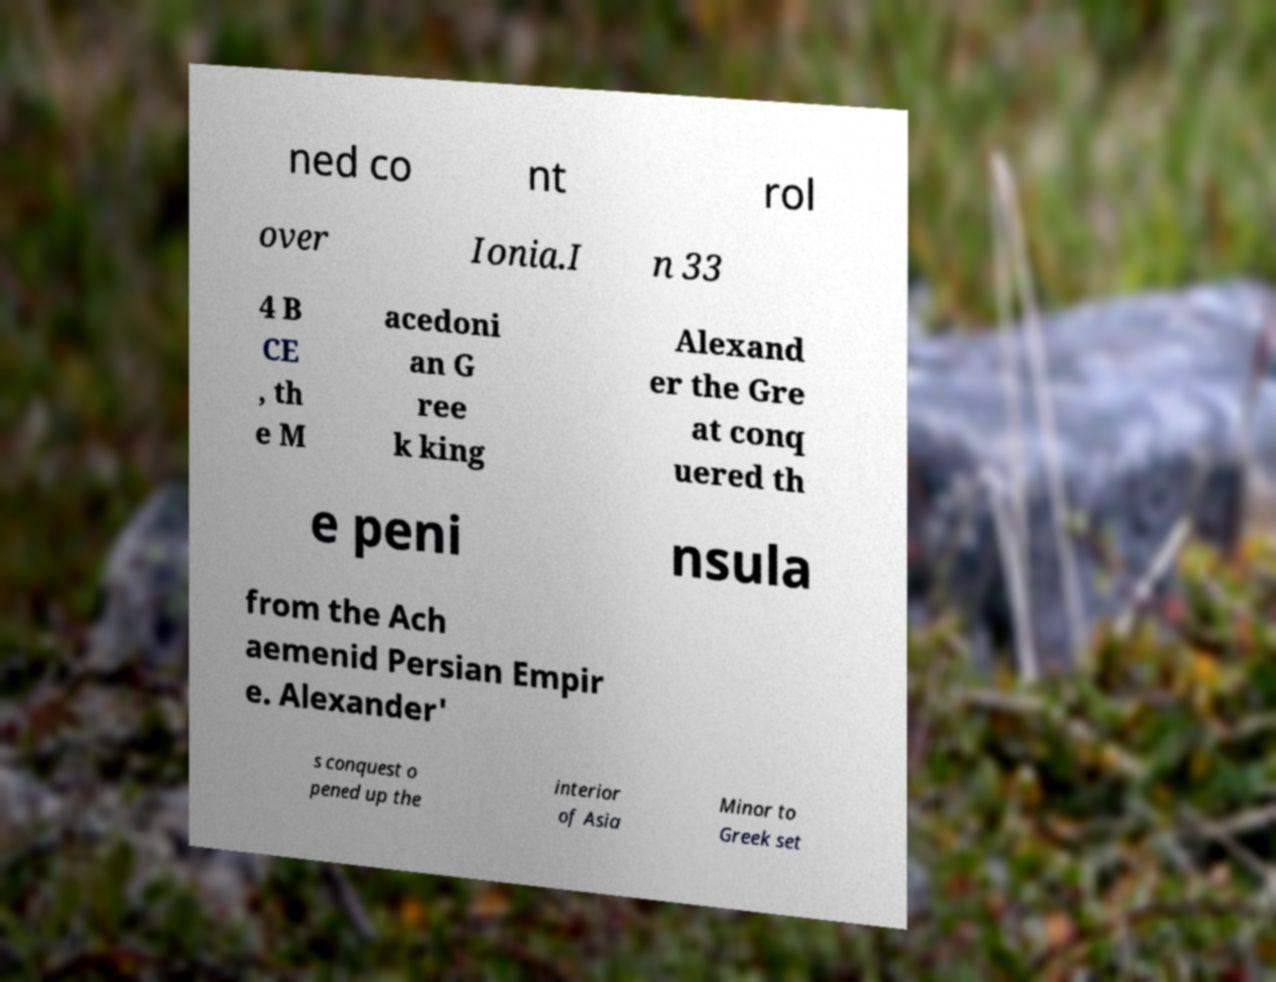Could you extract and type out the text from this image? ned co nt rol over Ionia.I n 33 4 B CE , th e M acedoni an G ree k king Alexand er the Gre at conq uered th e peni nsula from the Ach aemenid Persian Empir e. Alexander' s conquest o pened up the interior of Asia Minor to Greek set 